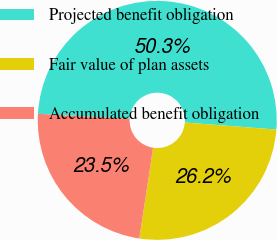Convert chart. <chart><loc_0><loc_0><loc_500><loc_500><pie_chart><fcel>Projected benefit obligation<fcel>Fair value of plan assets<fcel>Accumulated benefit obligation<nl><fcel>50.35%<fcel>26.17%<fcel>23.48%<nl></chart> 